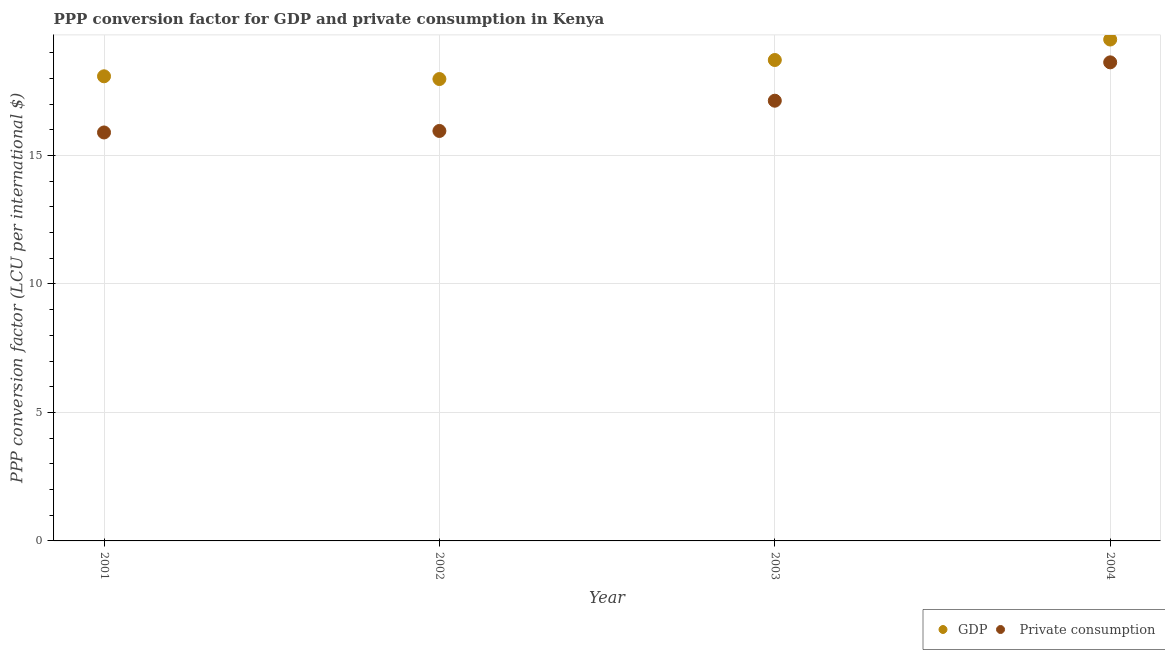Is the number of dotlines equal to the number of legend labels?
Make the answer very short. Yes. What is the ppp conversion factor for gdp in 2001?
Provide a short and direct response. 18.08. Across all years, what is the maximum ppp conversion factor for gdp?
Make the answer very short. 19.51. Across all years, what is the minimum ppp conversion factor for gdp?
Your answer should be compact. 17.98. What is the total ppp conversion factor for gdp in the graph?
Provide a succinct answer. 74.29. What is the difference between the ppp conversion factor for private consumption in 2001 and that in 2002?
Ensure brevity in your answer.  -0.06. What is the difference between the ppp conversion factor for gdp in 2001 and the ppp conversion factor for private consumption in 2002?
Give a very brief answer. 2.13. What is the average ppp conversion factor for gdp per year?
Your response must be concise. 18.57. In the year 2003, what is the difference between the ppp conversion factor for private consumption and ppp conversion factor for gdp?
Keep it short and to the point. -1.58. What is the ratio of the ppp conversion factor for private consumption in 2002 to that in 2004?
Offer a terse response. 0.86. Is the ppp conversion factor for private consumption in 2002 less than that in 2003?
Provide a short and direct response. Yes. What is the difference between the highest and the second highest ppp conversion factor for private consumption?
Give a very brief answer. 1.49. What is the difference between the highest and the lowest ppp conversion factor for gdp?
Offer a very short reply. 1.54. Is the ppp conversion factor for gdp strictly greater than the ppp conversion factor for private consumption over the years?
Offer a very short reply. Yes. Is the ppp conversion factor for gdp strictly less than the ppp conversion factor for private consumption over the years?
Provide a succinct answer. No. How many years are there in the graph?
Your answer should be very brief. 4. Does the graph contain any zero values?
Offer a terse response. No. Does the graph contain grids?
Your answer should be very brief. Yes. Where does the legend appear in the graph?
Your answer should be compact. Bottom right. How many legend labels are there?
Provide a short and direct response. 2. How are the legend labels stacked?
Provide a short and direct response. Horizontal. What is the title of the graph?
Keep it short and to the point. PPP conversion factor for GDP and private consumption in Kenya. What is the label or title of the X-axis?
Give a very brief answer. Year. What is the label or title of the Y-axis?
Offer a terse response. PPP conversion factor (LCU per international $). What is the PPP conversion factor (LCU per international $) of GDP in 2001?
Ensure brevity in your answer.  18.08. What is the PPP conversion factor (LCU per international $) in  Private consumption in 2001?
Provide a short and direct response. 15.9. What is the PPP conversion factor (LCU per international $) of GDP in 2002?
Your response must be concise. 17.98. What is the PPP conversion factor (LCU per international $) in  Private consumption in 2002?
Give a very brief answer. 15.96. What is the PPP conversion factor (LCU per international $) of GDP in 2003?
Provide a short and direct response. 18.72. What is the PPP conversion factor (LCU per international $) in  Private consumption in 2003?
Offer a terse response. 17.13. What is the PPP conversion factor (LCU per international $) of GDP in 2004?
Your answer should be compact. 19.51. What is the PPP conversion factor (LCU per international $) in  Private consumption in 2004?
Keep it short and to the point. 18.63. Across all years, what is the maximum PPP conversion factor (LCU per international $) in GDP?
Your answer should be compact. 19.51. Across all years, what is the maximum PPP conversion factor (LCU per international $) in  Private consumption?
Your response must be concise. 18.63. Across all years, what is the minimum PPP conversion factor (LCU per international $) of GDP?
Offer a terse response. 17.98. Across all years, what is the minimum PPP conversion factor (LCU per international $) in  Private consumption?
Keep it short and to the point. 15.9. What is the total PPP conversion factor (LCU per international $) of GDP in the graph?
Provide a short and direct response. 74.29. What is the total PPP conversion factor (LCU per international $) in  Private consumption in the graph?
Make the answer very short. 67.61. What is the difference between the PPP conversion factor (LCU per international $) of GDP in 2001 and that in 2002?
Your answer should be very brief. 0.11. What is the difference between the PPP conversion factor (LCU per international $) in  Private consumption in 2001 and that in 2002?
Give a very brief answer. -0.06. What is the difference between the PPP conversion factor (LCU per international $) in GDP in 2001 and that in 2003?
Offer a very short reply. -0.63. What is the difference between the PPP conversion factor (LCU per international $) in  Private consumption in 2001 and that in 2003?
Offer a terse response. -1.24. What is the difference between the PPP conversion factor (LCU per international $) of GDP in 2001 and that in 2004?
Your answer should be very brief. -1.43. What is the difference between the PPP conversion factor (LCU per international $) in  Private consumption in 2001 and that in 2004?
Offer a very short reply. -2.73. What is the difference between the PPP conversion factor (LCU per international $) in GDP in 2002 and that in 2003?
Your response must be concise. -0.74. What is the difference between the PPP conversion factor (LCU per international $) of  Private consumption in 2002 and that in 2003?
Your answer should be compact. -1.18. What is the difference between the PPP conversion factor (LCU per international $) in GDP in 2002 and that in 2004?
Keep it short and to the point. -1.54. What is the difference between the PPP conversion factor (LCU per international $) in  Private consumption in 2002 and that in 2004?
Give a very brief answer. -2.67. What is the difference between the PPP conversion factor (LCU per international $) in GDP in 2003 and that in 2004?
Your response must be concise. -0.8. What is the difference between the PPP conversion factor (LCU per international $) in  Private consumption in 2003 and that in 2004?
Make the answer very short. -1.49. What is the difference between the PPP conversion factor (LCU per international $) in GDP in 2001 and the PPP conversion factor (LCU per international $) in  Private consumption in 2002?
Make the answer very short. 2.13. What is the difference between the PPP conversion factor (LCU per international $) in GDP in 2001 and the PPP conversion factor (LCU per international $) in  Private consumption in 2003?
Offer a terse response. 0.95. What is the difference between the PPP conversion factor (LCU per international $) of GDP in 2001 and the PPP conversion factor (LCU per international $) of  Private consumption in 2004?
Keep it short and to the point. -0.54. What is the difference between the PPP conversion factor (LCU per international $) of GDP in 2002 and the PPP conversion factor (LCU per international $) of  Private consumption in 2003?
Provide a short and direct response. 0.84. What is the difference between the PPP conversion factor (LCU per international $) in GDP in 2002 and the PPP conversion factor (LCU per international $) in  Private consumption in 2004?
Give a very brief answer. -0.65. What is the difference between the PPP conversion factor (LCU per international $) in GDP in 2003 and the PPP conversion factor (LCU per international $) in  Private consumption in 2004?
Make the answer very short. 0.09. What is the average PPP conversion factor (LCU per international $) in GDP per year?
Provide a short and direct response. 18.57. What is the average PPP conversion factor (LCU per international $) of  Private consumption per year?
Make the answer very short. 16.9. In the year 2001, what is the difference between the PPP conversion factor (LCU per international $) in GDP and PPP conversion factor (LCU per international $) in  Private consumption?
Your answer should be very brief. 2.19. In the year 2002, what is the difference between the PPP conversion factor (LCU per international $) in GDP and PPP conversion factor (LCU per international $) in  Private consumption?
Your response must be concise. 2.02. In the year 2003, what is the difference between the PPP conversion factor (LCU per international $) in GDP and PPP conversion factor (LCU per international $) in  Private consumption?
Provide a short and direct response. 1.58. In the year 2004, what is the difference between the PPP conversion factor (LCU per international $) in GDP and PPP conversion factor (LCU per international $) in  Private consumption?
Your answer should be compact. 0.89. What is the ratio of the PPP conversion factor (LCU per international $) of GDP in 2001 to that in 2002?
Offer a very short reply. 1.01. What is the ratio of the PPP conversion factor (LCU per international $) of GDP in 2001 to that in 2003?
Ensure brevity in your answer.  0.97. What is the ratio of the PPP conversion factor (LCU per international $) of  Private consumption in 2001 to that in 2003?
Provide a succinct answer. 0.93. What is the ratio of the PPP conversion factor (LCU per international $) of GDP in 2001 to that in 2004?
Offer a terse response. 0.93. What is the ratio of the PPP conversion factor (LCU per international $) of  Private consumption in 2001 to that in 2004?
Your response must be concise. 0.85. What is the ratio of the PPP conversion factor (LCU per international $) of GDP in 2002 to that in 2003?
Give a very brief answer. 0.96. What is the ratio of the PPP conversion factor (LCU per international $) of  Private consumption in 2002 to that in 2003?
Give a very brief answer. 0.93. What is the ratio of the PPP conversion factor (LCU per international $) in GDP in 2002 to that in 2004?
Provide a succinct answer. 0.92. What is the ratio of the PPP conversion factor (LCU per international $) of  Private consumption in 2002 to that in 2004?
Give a very brief answer. 0.86. What is the ratio of the PPP conversion factor (LCU per international $) in GDP in 2003 to that in 2004?
Keep it short and to the point. 0.96. What is the ratio of the PPP conversion factor (LCU per international $) of  Private consumption in 2003 to that in 2004?
Offer a terse response. 0.92. What is the difference between the highest and the second highest PPP conversion factor (LCU per international $) in GDP?
Your answer should be very brief. 0.8. What is the difference between the highest and the second highest PPP conversion factor (LCU per international $) in  Private consumption?
Ensure brevity in your answer.  1.49. What is the difference between the highest and the lowest PPP conversion factor (LCU per international $) of GDP?
Offer a very short reply. 1.54. What is the difference between the highest and the lowest PPP conversion factor (LCU per international $) in  Private consumption?
Make the answer very short. 2.73. 